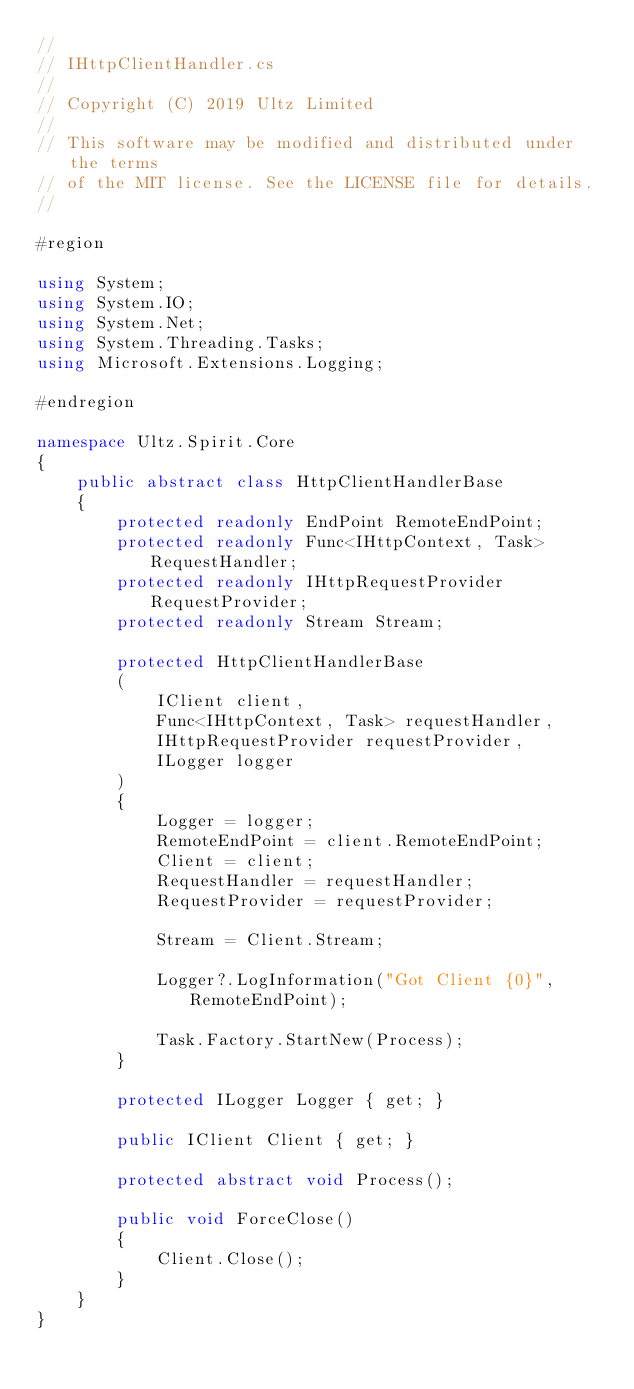Convert code to text. <code><loc_0><loc_0><loc_500><loc_500><_C#_>// 
// IHttpClientHandler.cs
// 
// Copyright (C) 2019 Ultz Limited
// 
// This software may be modified and distributed under the terms
// of the MIT license. See the LICENSE file for details.
// 

#region

using System;
using System.IO;
using System.Net;
using System.Threading.Tasks;
using Microsoft.Extensions.Logging;

#endregion

namespace Ultz.Spirit.Core
{
    public abstract class HttpClientHandlerBase
    {
        protected readonly EndPoint RemoteEndPoint;
        protected readonly Func<IHttpContext, Task> RequestHandler;
        protected readonly IHttpRequestProvider RequestProvider;
        protected readonly Stream Stream;

        protected HttpClientHandlerBase
        (
            IClient client,
            Func<IHttpContext, Task> requestHandler,
            IHttpRequestProvider requestProvider,
            ILogger logger
        )
        {
            Logger = logger;
            RemoteEndPoint = client.RemoteEndPoint;
            Client = client;
            RequestHandler = requestHandler;
            RequestProvider = requestProvider;

            Stream = Client.Stream;

            Logger?.LogInformation("Got Client {0}", RemoteEndPoint);

            Task.Factory.StartNew(Process);
        }

        protected ILogger Logger { get; }

        public IClient Client { get; }

        protected abstract void Process();

        public void ForceClose()
        {
            Client.Close();
        }
    }
}
</code> 